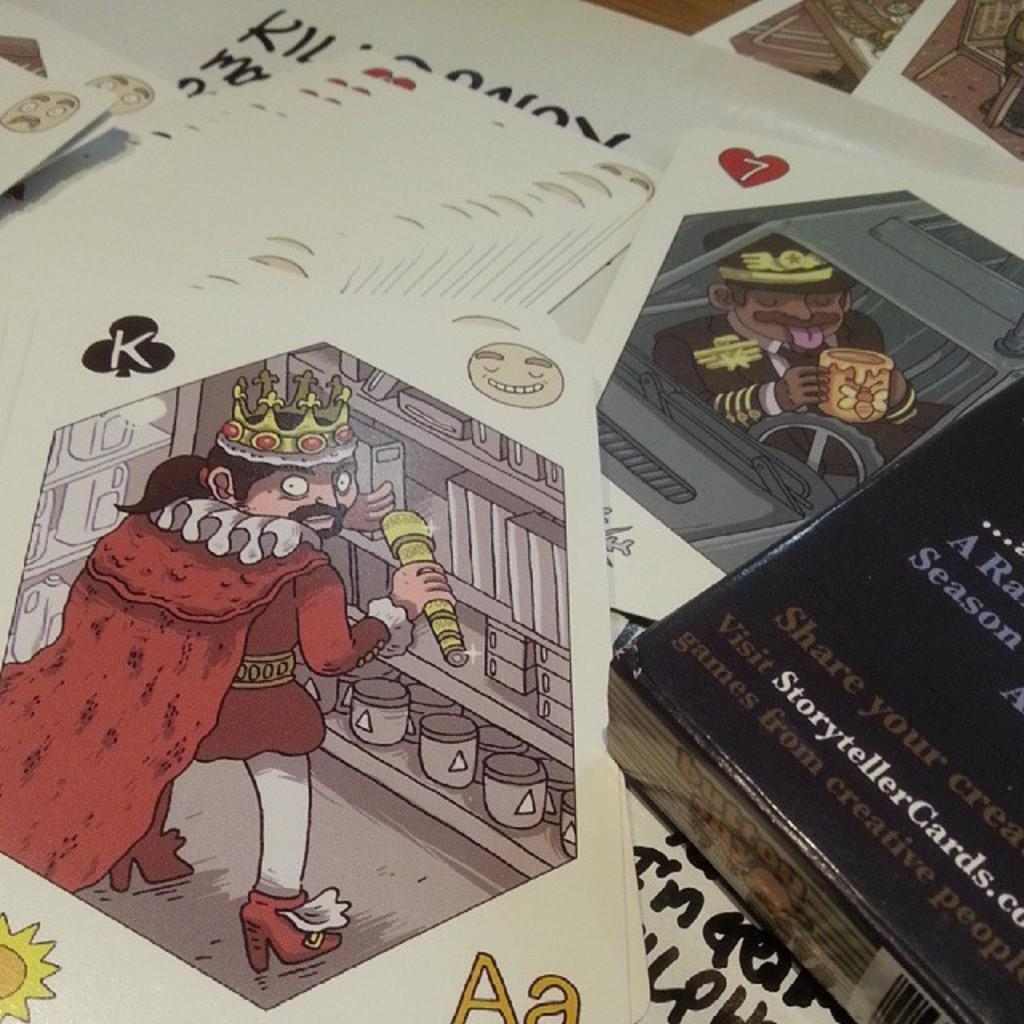<image>
Write a terse but informative summary of the picture. Cartoon with a king and his crown from StorytellerCards.com 